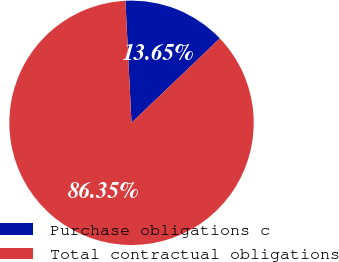<chart> <loc_0><loc_0><loc_500><loc_500><pie_chart><fcel>Purchase obligations c<fcel>Total contractual obligations<nl><fcel>13.65%<fcel>86.35%<nl></chart> 